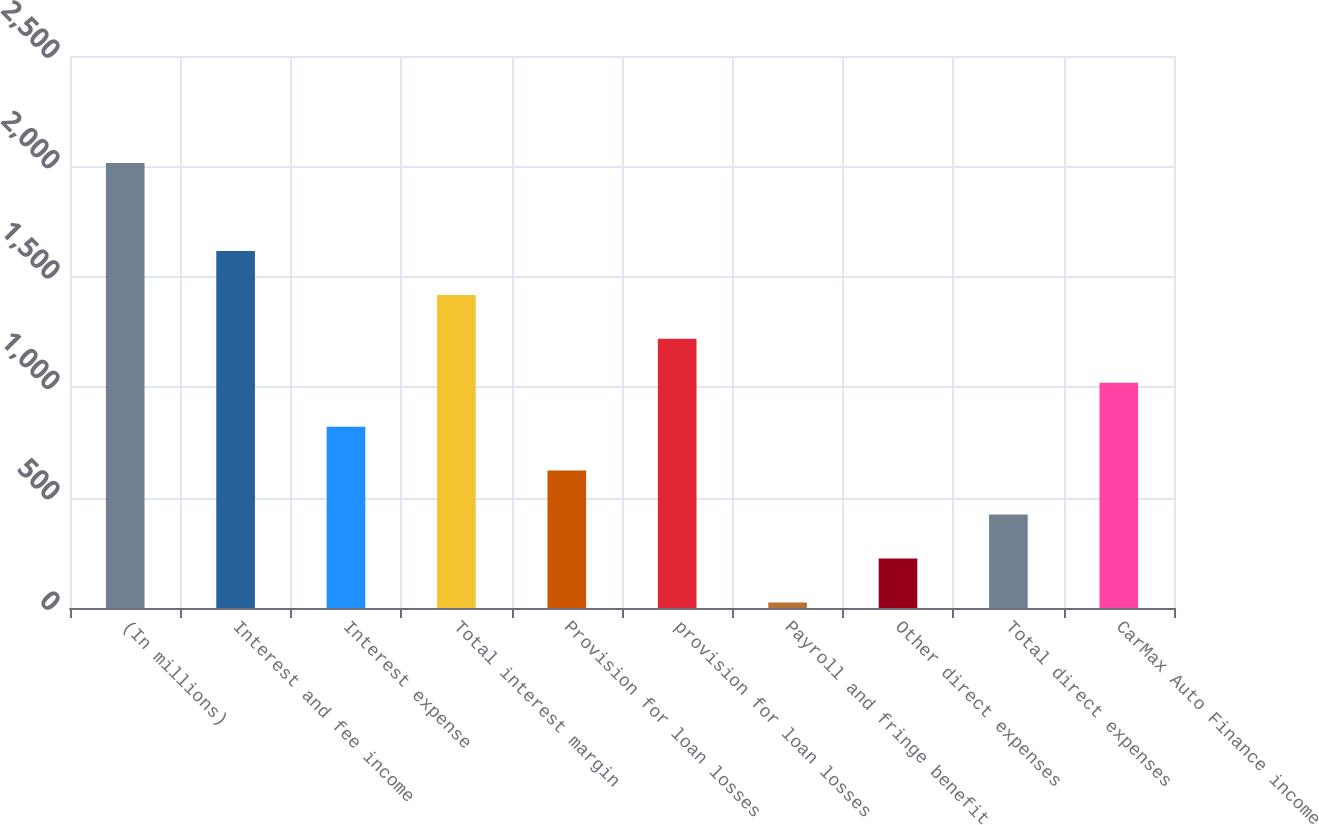Convert chart to OTSL. <chart><loc_0><loc_0><loc_500><loc_500><bar_chart><fcel>(In millions)<fcel>Interest and fee income<fcel>Interest expense<fcel>Total interest margin<fcel>Provision for loan losses<fcel>provision for loan losses<fcel>Payroll and fringe benefit<fcel>Other direct expenses<fcel>Total direct expenses<fcel>CarMax Auto Finance income<nl><fcel>2015<fcel>1617.06<fcel>821.18<fcel>1418.09<fcel>622.21<fcel>1219.12<fcel>25.3<fcel>224.27<fcel>423.24<fcel>1020.15<nl></chart> 